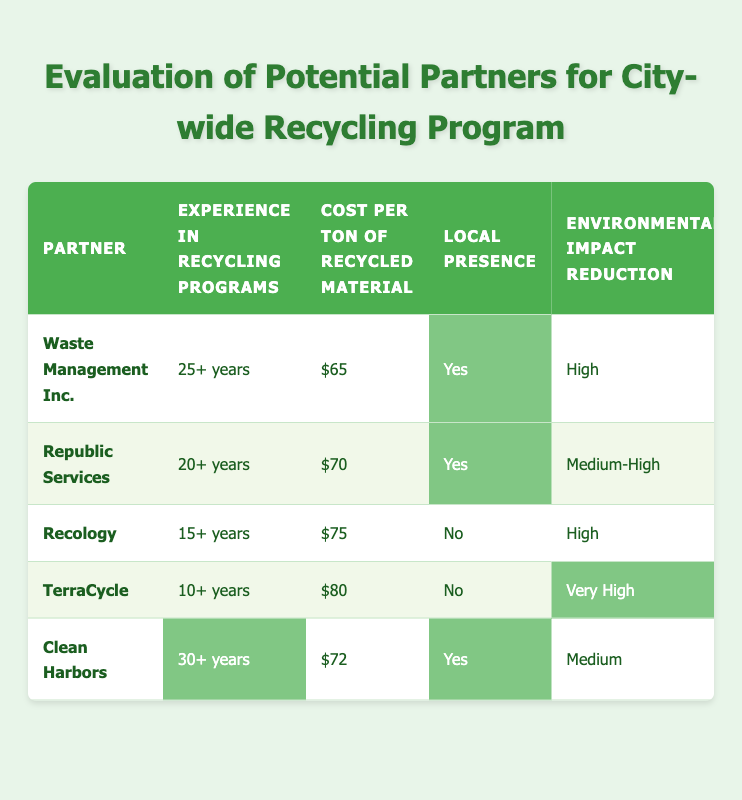What is the cost per ton of recycled material for Waste Management Inc.? Looking at the row for Waste Management Inc., the column labeled "Cost per ton of recycled material" shows "$65".
Answer: $65 Which partner has the highest experience in recycling programs? By comparing the "Experience in recycling programs" for each partner, Clean Harbors with "30+ years" shows the most experience.
Answer: Clean Harbors Do both Recology and TerraCycle have a local presence? The data shows that Recology has "No" and TerraCycle has "No" under the "Local presence" column, confirming neither has a local presence.
Answer: No What is the average cost per ton of recycled material for the partners with local presence? The cost per ton for Waste Management Inc. is $65 and for Clean Harbors it is $72. Adding both gives $137, and then dividing by 2 results in an average of $68.5.
Answer: $68.5 Based on the environmental impact reduction, which partner has the lowest impact? Reviewing the "Environmental impact reduction" column, Clean Harbors has "Medium," which is lower than others like Waste Management Inc. (High) and others with Very High or Medium-High.
Answer: Clean Harbors How many partners have extensive or excellent education and outreach capabilities? In the "Education and outreach capabilities" column, Waste Management Inc. has "Extensive," and TerraCycle has "Excellent," making it a total of 2 partners with those capabilities.
Answer: 2 Is the cost per ton of recycled material higher for Recology than for Republic Services? Comparing the costs, Recology is $75, which is higher than Republic Services at $70. Therefore, Recology does have a higher cost.
Answer: Yes Which partner has the lowest environmental impact reduction rating? The "Environmental impact reduction" ratings show that Clean Harbors has "Medium," which is the lowest rating compared to others.
Answer: Clean Harbors What is the total experience in years of all partners combined? Adding the experience: 25 + 20 + 15 + 10 + 30 gives a total of 100 years.
Answer: 100 